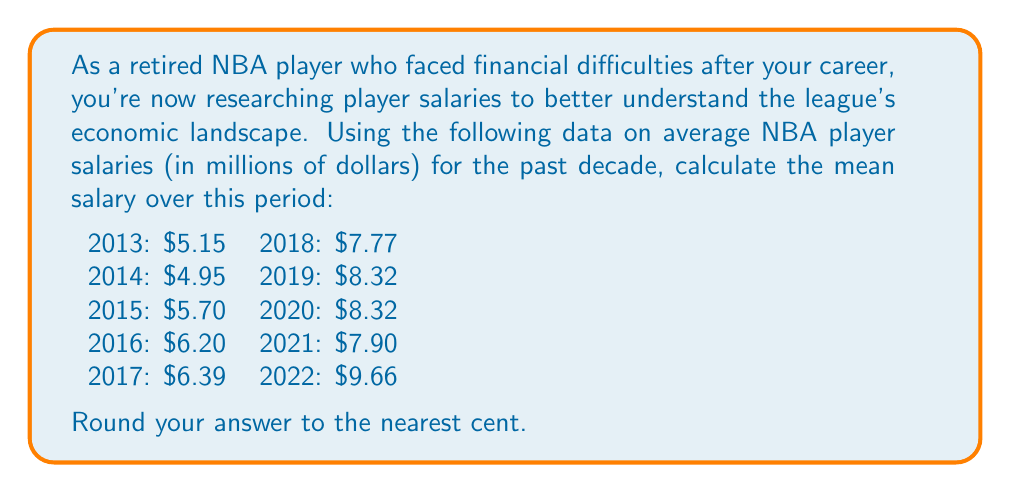Can you answer this question? To calculate the mean salary over the past decade, we need to follow these steps:

1. Sum up all the salaries:
   $$5.15 + 4.95 + 5.70 + 6.20 + 6.39 + 7.77 + 8.32 + 8.32 + 7.90 + 9.66 = 70.36$$

2. Count the number of years: 10

3. Apply the formula for the arithmetic mean:
   $$\text{Mean} = \frac{\text{Sum of values}}{\text{Number of values}}$$

4. Substitute the values:
   $$\text{Mean} = \frac{70.36}{10} = 7.036$$

5. Round to the nearest cent:
   $$7.04$$

Therefore, the average NBA player salary over the past decade is $7.04 million.
Answer: $7.04 million 